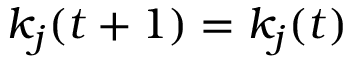<formula> <loc_0><loc_0><loc_500><loc_500>k _ { j } ( t + 1 ) = k _ { j } ( t )</formula> 